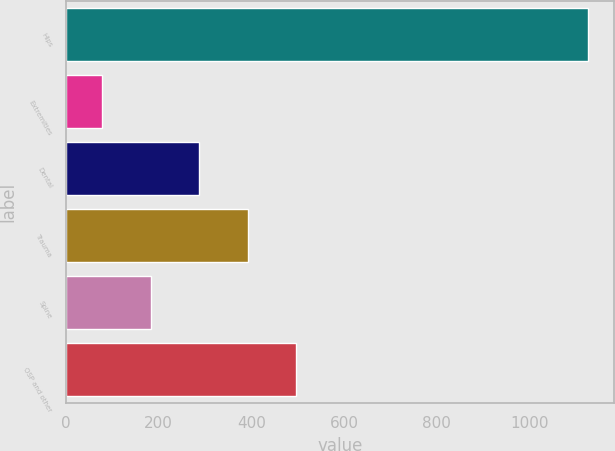Convert chart to OTSL. <chart><loc_0><loc_0><loc_500><loc_500><bar_chart><fcel>Hips<fcel>Extremities<fcel>Dental<fcel>Trauma<fcel>Spine<fcel>OSP and other<nl><fcel>1126.9<fcel>77.6<fcel>287.46<fcel>392.39<fcel>182.53<fcel>497.32<nl></chart> 